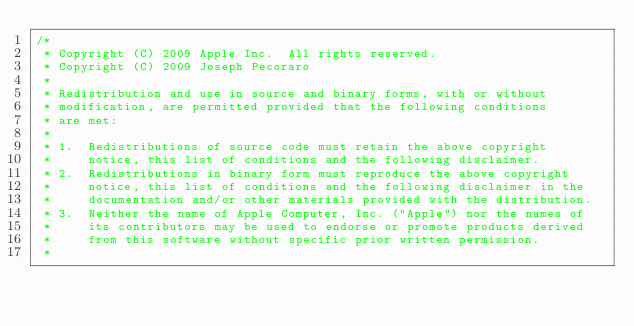Convert code to text. <code><loc_0><loc_0><loc_500><loc_500><_JavaScript_>/*
 * Copyright (C) 2009 Apple Inc.  All rights reserved.
 * Copyright (C) 2009 Joseph Pecoraro
 *
 * Redistribution and use in source and binary forms, with or without
 * modification, are permitted provided that the following conditions
 * are met:
 *
 * 1.  Redistributions of source code must retain the above copyright
 *     notice, this list of conditions and the following disclaimer.
 * 2.  Redistributions in binary form must reproduce the above copyright
 *     notice, this list of conditions and the following disclaimer in the
 *     documentation and/or other materials provided with the distribution.
 * 3.  Neither the name of Apple Computer, Inc. ("Apple") nor the names of
 *     its contributors may be used to endorse or promote products derived
 *     from this software without specific prior written permission.
 *</code> 